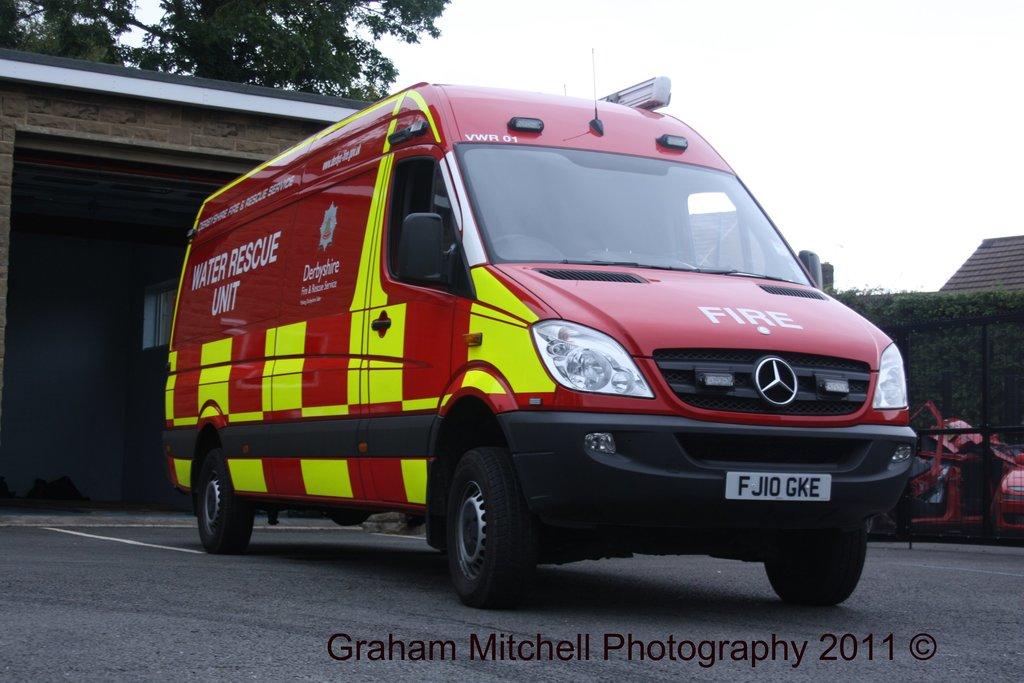What does it say on this van's hood?
Give a very brief answer. Fire. What is the license plate number?
Keep it short and to the point. Fjiogke. 